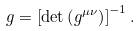Convert formula to latex. <formula><loc_0><loc_0><loc_500><loc_500>g = \left [ \det \left ( g ^ { \mu \nu } \right ) \right ] ^ { - 1 } .</formula> 